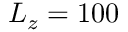Convert formula to latex. <formula><loc_0><loc_0><loc_500><loc_500>L _ { z } = 1 0 0</formula> 